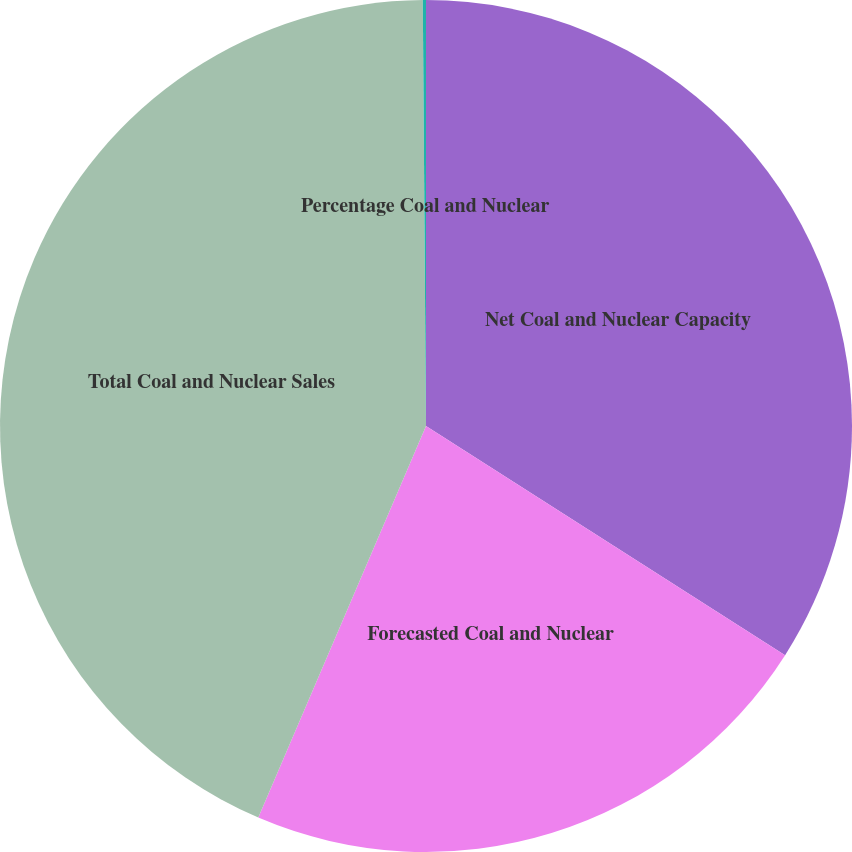<chart> <loc_0><loc_0><loc_500><loc_500><pie_chart><fcel>Net Coal and Nuclear Capacity<fcel>Forecasted Coal and Nuclear<fcel>Total Coal and Nuclear Sales<fcel>Percentage Coal and Nuclear<nl><fcel>34.04%<fcel>22.4%<fcel>43.44%<fcel>0.12%<nl></chart> 